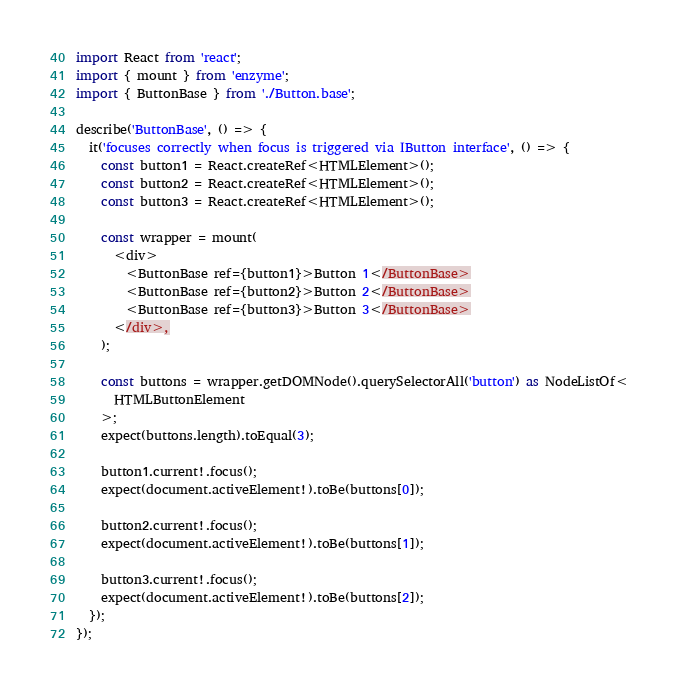<code> <loc_0><loc_0><loc_500><loc_500><_TypeScript_>import React from 'react';
import { mount } from 'enzyme';
import { ButtonBase } from './Button.base';

describe('ButtonBase', () => {
  it('focuses correctly when focus is triggered via IButton interface', () => {
    const button1 = React.createRef<HTMLElement>();
    const button2 = React.createRef<HTMLElement>();
    const button3 = React.createRef<HTMLElement>();

    const wrapper = mount(
      <div>
        <ButtonBase ref={button1}>Button 1</ButtonBase>
        <ButtonBase ref={button2}>Button 2</ButtonBase>
        <ButtonBase ref={button3}>Button 3</ButtonBase>
      </div>,
    );

    const buttons = wrapper.getDOMNode().querySelectorAll('button') as NodeListOf<
      HTMLButtonElement
    >;
    expect(buttons.length).toEqual(3);

    button1.current!.focus();
    expect(document.activeElement!).toBe(buttons[0]);

    button2.current!.focus();
    expect(document.activeElement!).toBe(buttons[1]);

    button3.current!.focus();
    expect(document.activeElement!).toBe(buttons[2]);
  });
});
</code> 